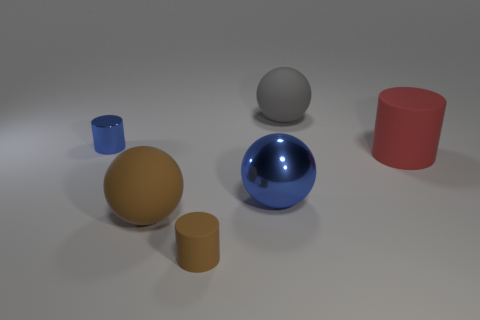Does the blue sphere on the left side of the gray object have the same size as the blue metallic object that is behind the large cylinder?
Provide a succinct answer. No. Is there a big red rubber thing that has the same shape as the big gray thing?
Ensure brevity in your answer.  No. Are there the same number of big rubber spheres that are left of the tiny brown rubber cylinder and gray metallic blocks?
Give a very brief answer. No. Does the gray object have the same size as the red matte thing behind the brown cylinder?
Provide a short and direct response. Yes. What number of big gray objects are made of the same material as the big red cylinder?
Your answer should be very brief. 1. Does the blue shiny sphere have the same size as the blue cylinder?
Give a very brief answer. No. Are there any other things that are the same color as the large metal thing?
Ensure brevity in your answer.  Yes. What is the shape of the object that is both behind the big cylinder and on the right side of the small shiny object?
Keep it short and to the point. Sphere. There is a rubber object to the right of the gray matte ball; what size is it?
Offer a very short reply. Large. There is a small thing that is in front of the matte cylinder that is to the right of the brown cylinder; what number of gray objects are right of it?
Provide a succinct answer. 1. 